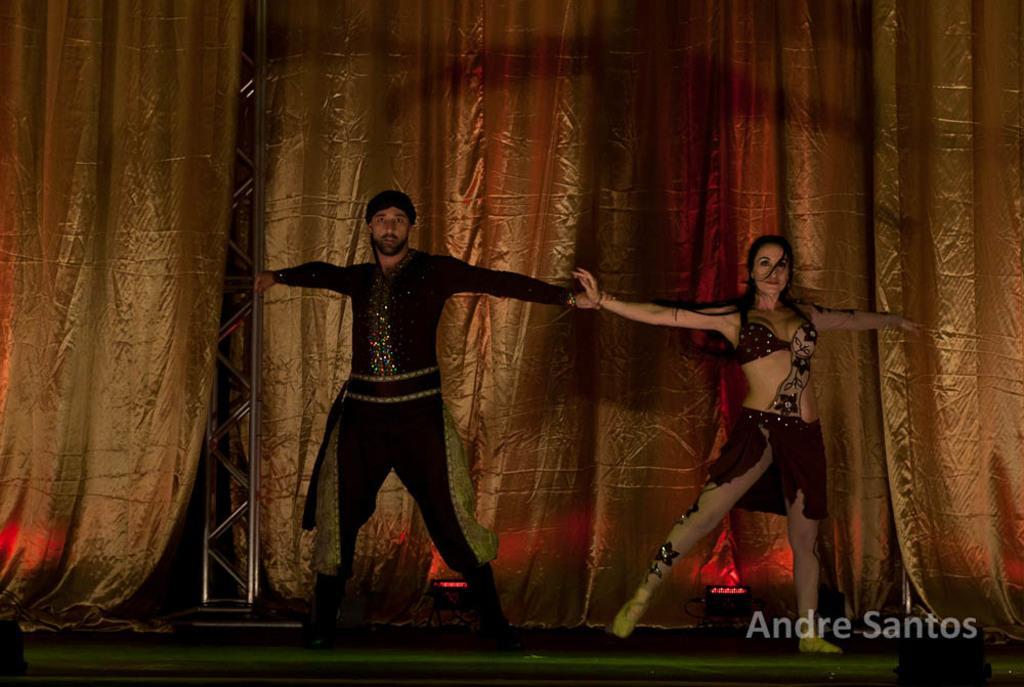Describe this image in one or two sentences. In this image there is a man and a woman dancing on the floor. Behind them there are lights on the floor. In the background there is a curtain. In the bottom right there is text on the image. 